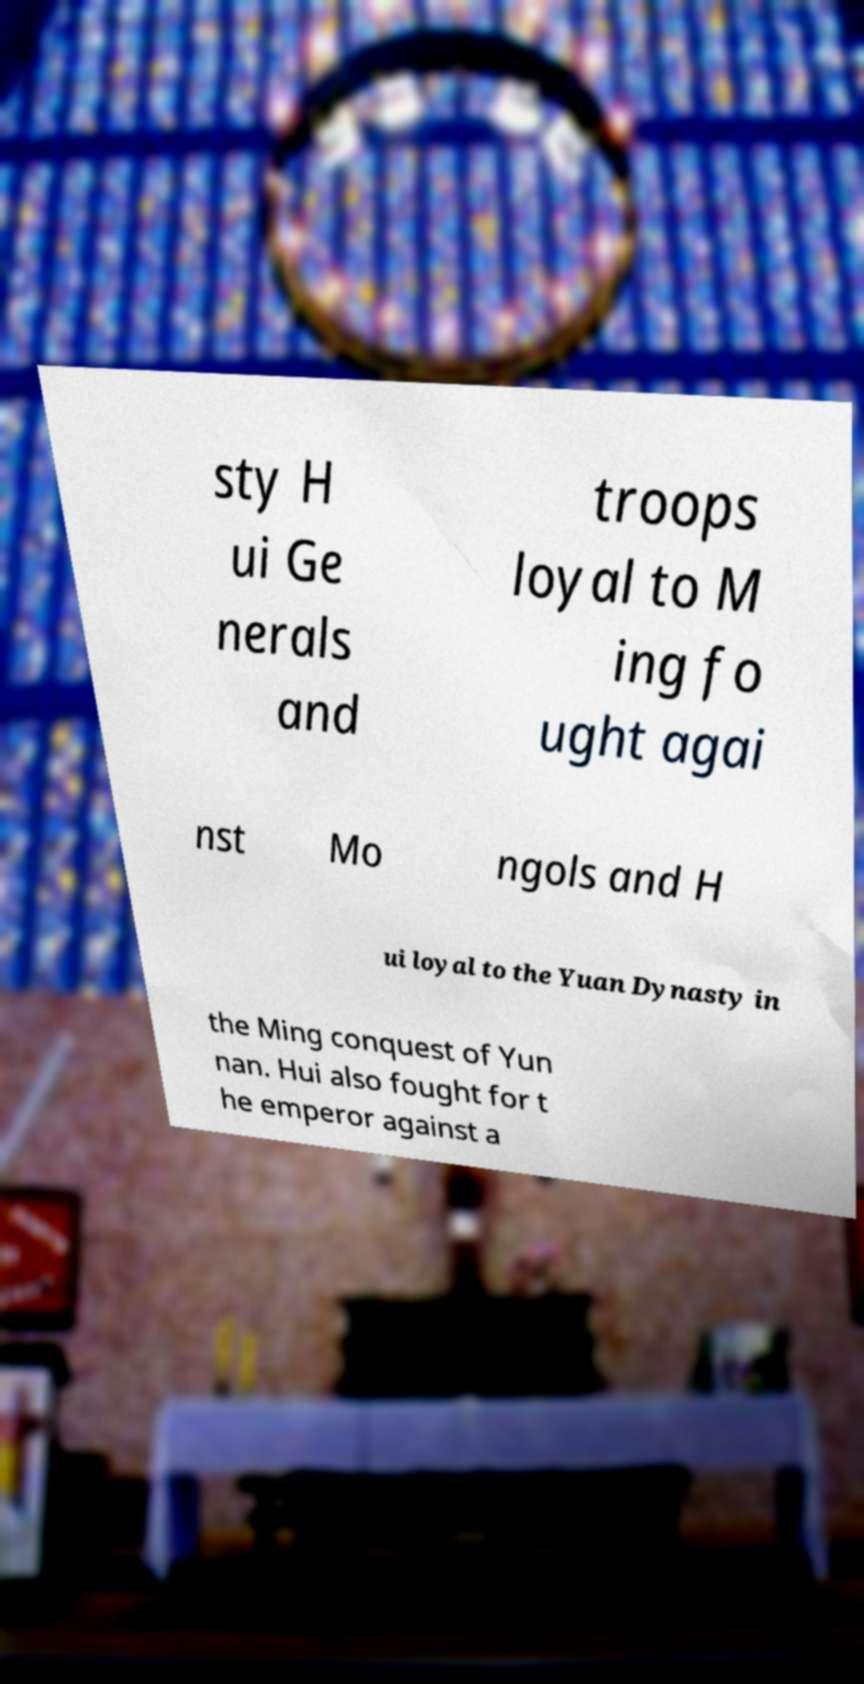There's text embedded in this image that I need extracted. Can you transcribe it verbatim? sty H ui Ge nerals and troops loyal to M ing fo ught agai nst Mo ngols and H ui loyal to the Yuan Dynasty in the Ming conquest of Yun nan. Hui also fought for t he emperor against a 